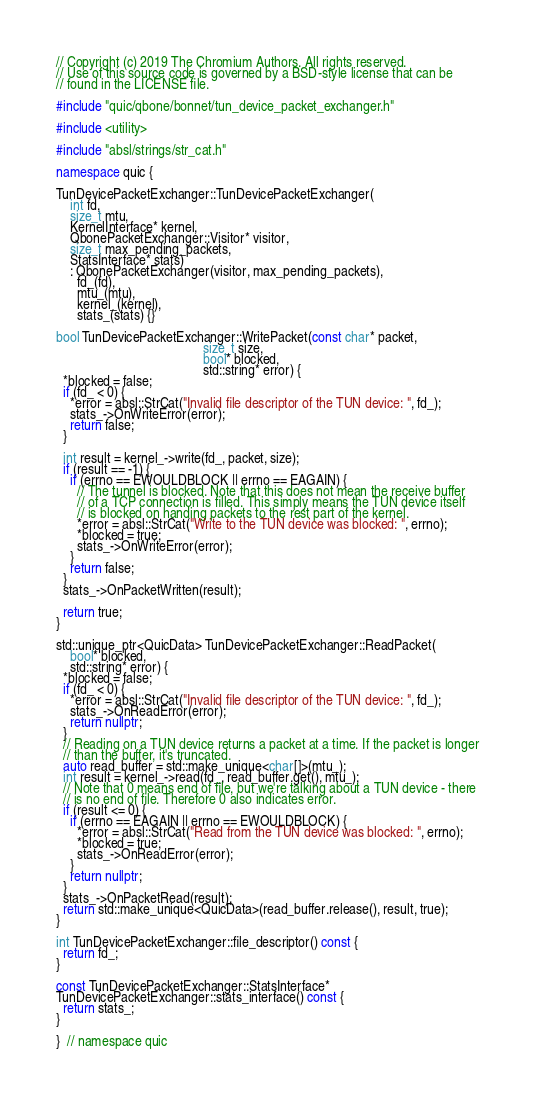Convert code to text. <code><loc_0><loc_0><loc_500><loc_500><_C++_>// Copyright (c) 2019 The Chromium Authors. All rights reserved.
// Use of this source code is governed by a BSD-style license that can be
// found in the LICENSE file.

#include "quic/qbone/bonnet/tun_device_packet_exchanger.h"

#include <utility>

#include "absl/strings/str_cat.h"

namespace quic {

TunDevicePacketExchanger::TunDevicePacketExchanger(
    int fd,
    size_t mtu,
    KernelInterface* kernel,
    QbonePacketExchanger::Visitor* visitor,
    size_t max_pending_packets,
    StatsInterface* stats)
    : QbonePacketExchanger(visitor, max_pending_packets),
      fd_(fd),
      mtu_(mtu),
      kernel_(kernel),
      stats_(stats) {}

bool TunDevicePacketExchanger::WritePacket(const char* packet,
                                           size_t size,
                                           bool* blocked,
                                           std::string* error) {
  *blocked = false;
  if (fd_ < 0) {
    *error = absl::StrCat("Invalid file descriptor of the TUN device: ", fd_);
    stats_->OnWriteError(error);
    return false;
  }

  int result = kernel_->write(fd_, packet, size);
  if (result == -1) {
    if (errno == EWOULDBLOCK || errno == EAGAIN) {
      // The tunnel is blocked. Note that this does not mean the receive buffer
      // of a TCP connection is filled. This simply means the TUN device itself
      // is blocked on handing packets to the rest part of the kernel.
      *error = absl::StrCat("Write to the TUN device was blocked: ", errno);
      *blocked = true;
      stats_->OnWriteError(error);
    }
    return false;
  }
  stats_->OnPacketWritten(result);

  return true;
}

std::unique_ptr<QuicData> TunDevicePacketExchanger::ReadPacket(
    bool* blocked,
    std::string* error) {
  *blocked = false;
  if (fd_ < 0) {
    *error = absl::StrCat("Invalid file descriptor of the TUN device: ", fd_);
    stats_->OnReadError(error);
    return nullptr;
  }
  // Reading on a TUN device returns a packet at a time. If the packet is longer
  // than the buffer, it's truncated.
  auto read_buffer = std::make_unique<char[]>(mtu_);
  int result = kernel_->read(fd_, read_buffer.get(), mtu_);
  // Note that 0 means end of file, but we're talking about a TUN device - there
  // is no end of file. Therefore 0 also indicates error.
  if (result <= 0) {
    if (errno == EAGAIN || errno == EWOULDBLOCK) {
      *error = absl::StrCat("Read from the TUN device was blocked: ", errno);
      *blocked = true;
      stats_->OnReadError(error);
    }
    return nullptr;
  }
  stats_->OnPacketRead(result);
  return std::make_unique<QuicData>(read_buffer.release(), result, true);
}

int TunDevicePacketExchanger::file_descriptor() const {
  return fd_;
}

const TunDevicePacketExchanger::StatsInterface*
TunDevicePacketExchanger::stats_interface() const {
  return stats_;
}

}  // namespace quic
</code> 